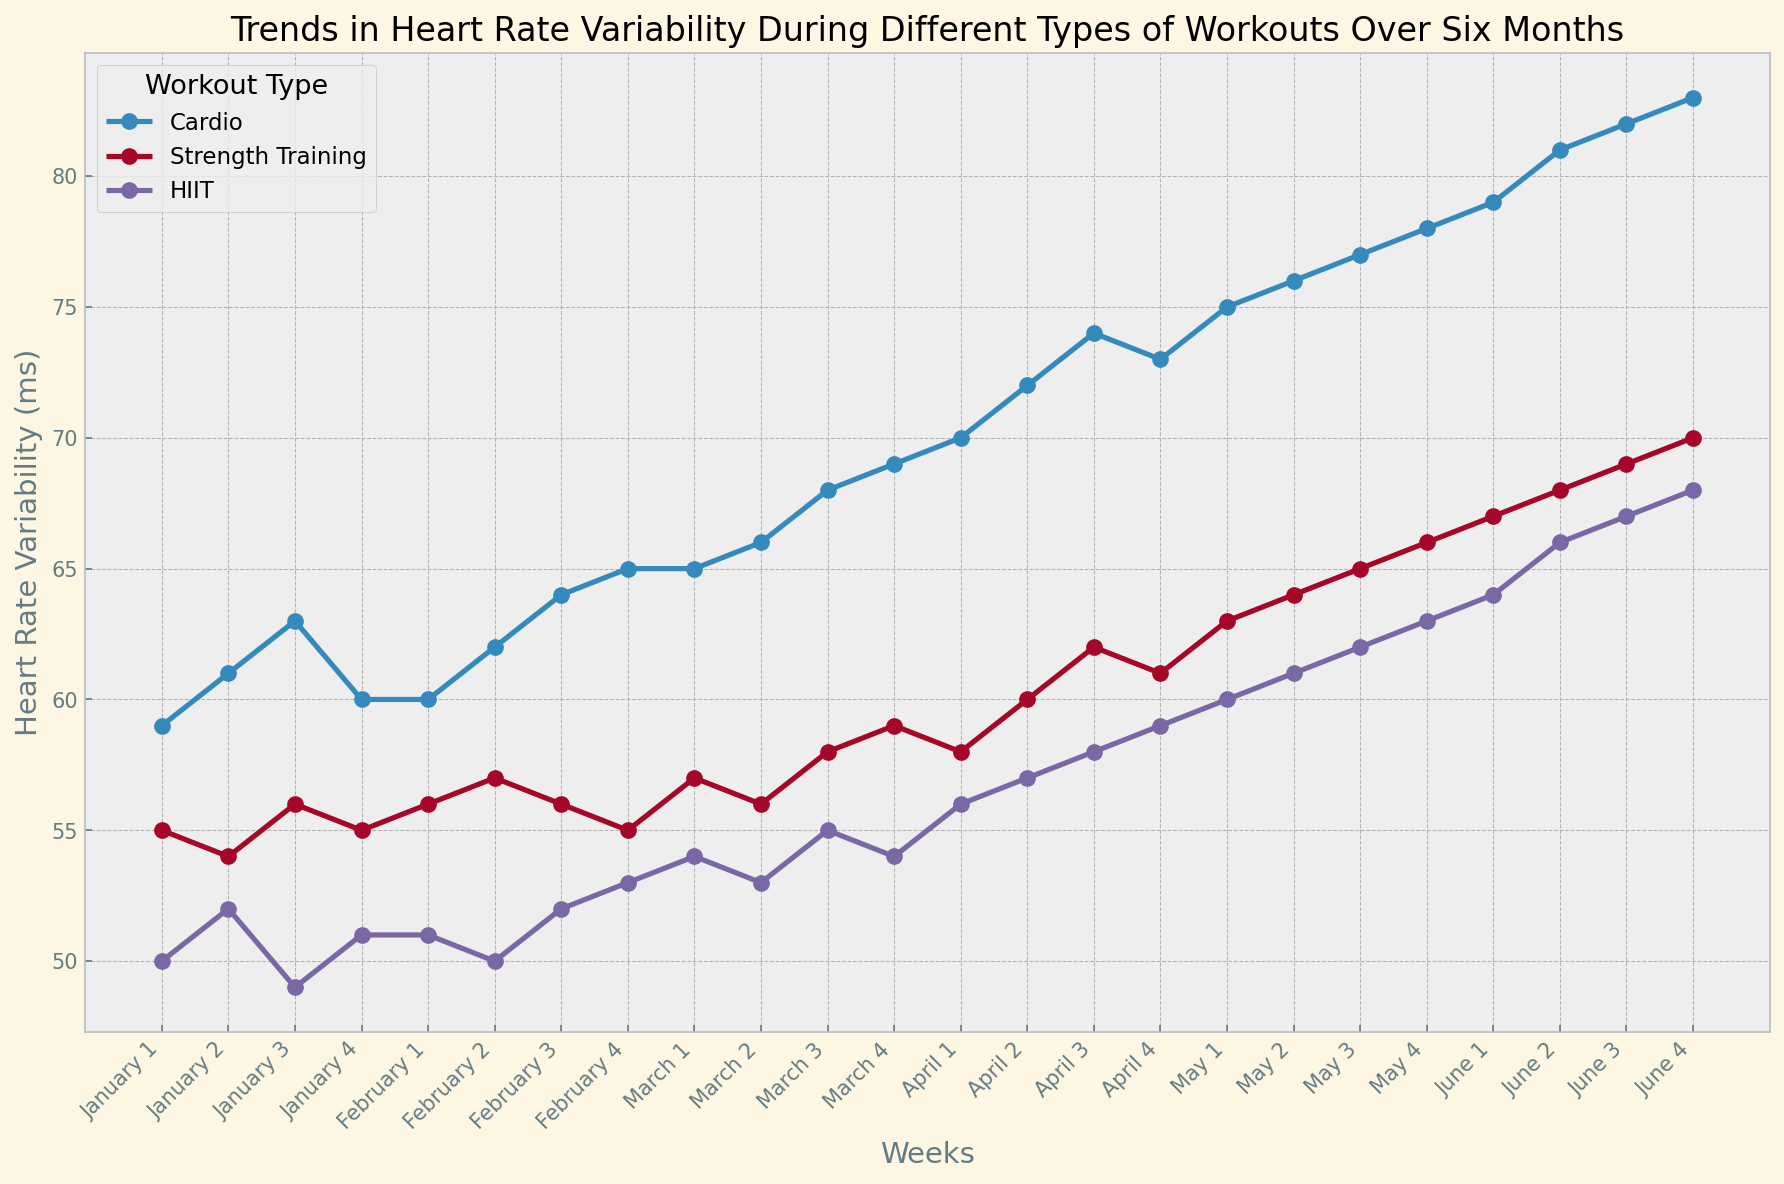What trend do we observe in the heart rate variability during cardio workouts over the six months? The heart rate variability during cardio workouts shows a consistently increasing trend from January to June. It starts from around 59 ms in January, peaking at around 83 ms in June.
Answer: Increasing trend Which workout type has the highest heart rate variability on average in June? To find this, observe the lines or points in June for each workout type. Cardio has values around 79–83 ms, strength training around 67–70 ms, and HIIT around 64–68 ms. Thus, Cardio has the highest heart rate variability on average in June.
Answer: Cardio What's the difference in heart rate variability between strength training and HIIT in April, Week 4? In April Week 4, the heart rate variability for strength training is 61 ms and for HIIT is 59 ms. The difference is 61 - 59 = 2 ms.
Answer: 2 ms How does the heart rate variability for HIIT workouts change between February and March? In February, the heart rate variability for HIIT ranges from 51 to 53 ms, and in March, it ranges from 54 to 55 ms. So, there is a small increase from February to March.
Answer: Small increase Compare the highest and lowest heart rate variability values for strength training over the six months. What do you notice? The highest value for strength training is found in June (70 ms), and the lowest value is found in January (54 ms). The variability increases over the six months.
Answer: Increases What's the average heart rate variability for strength training in January? Heart rate variability for strength training in January weeks are 55, 54, 56, and 55 ms. The average is (55 + 54 + 56 + 55) / 4 = 55 ms.
Answer: 55 ms Which workout type had the most significant increase in heart rate variability from January to February? Compare the increases from January to February for all workout types. Cardio increases from 59-61 ms to 60-65 ms, strength training stays almost the same, and HIIT slightly increases. Cardio has the most significant increase.
Answer: Cardio In which month does the heart rate variability for HIIT surpass that of strength training? In May, the values for HIIT (60-63 ms) surpass the values for strength training (63-66 ms). So, it is in May.
Answer: May 